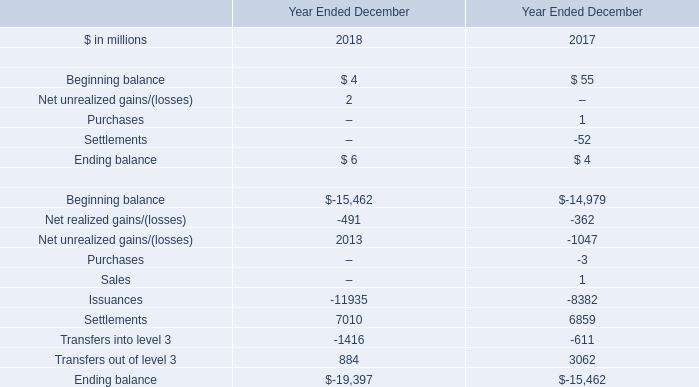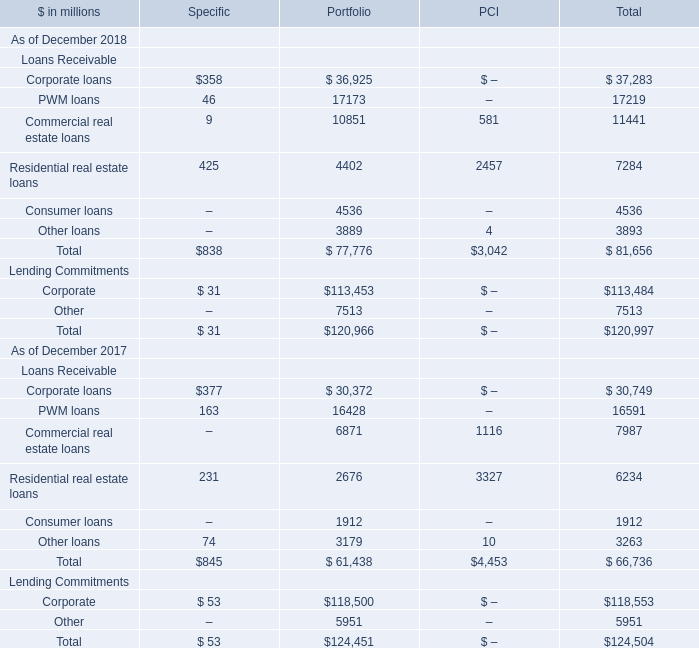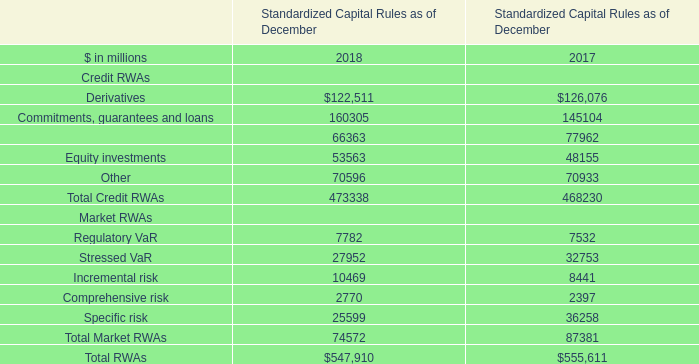what was net interest income in the consolidated statements of earnings in billions for 2016? 
Computations: (((100 - 13) / 100) * 2.93)
Answer: 2.5491. 